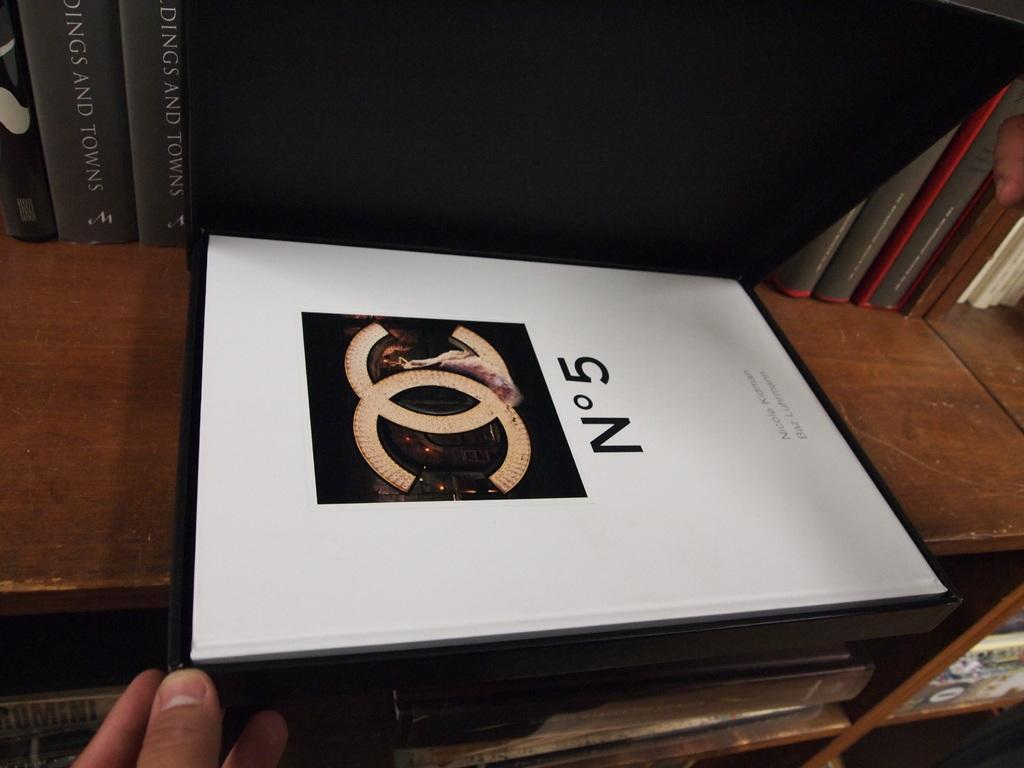<image>
Relay a brief, clear account of the picture shown. A box that has Chanel No 5 on the front of it. 